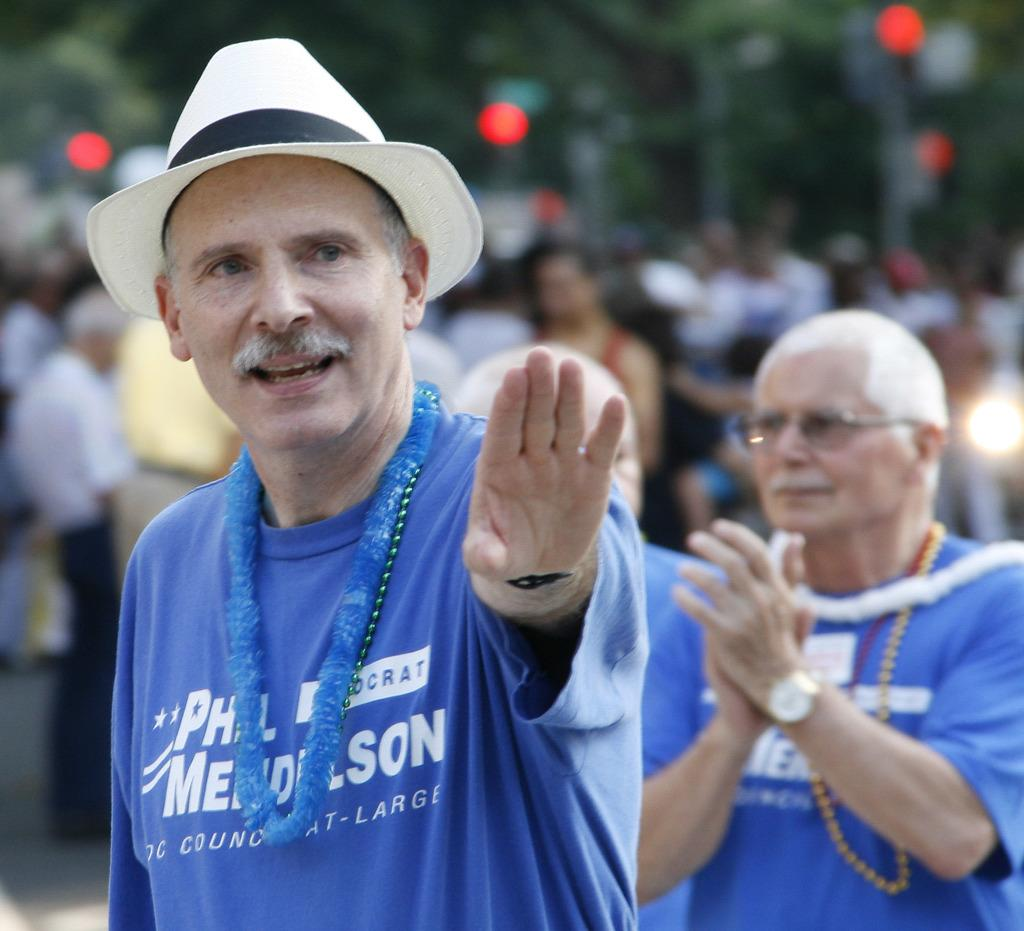What is one accessory worn by a person in the image? There is a person wearing a cap in the image. What is another accessory worn by a person in the image? There is a person wearing spectacles in the image. Can you describe the background of the image? There are people standing in the background of the image, and trees are visible as well. Is there a stream visible in the image? There is no stream present in the image. Is there a battle scene taking place in the image? There is no battle scene present in the image. 